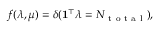<formula> <loc_0><loc_0><loc_500><loc_500>f ( \lambda , \mu ) = \delta ( 1 ^ { \top } \lambda = N _ { t o t a l } ) ,</formula> 